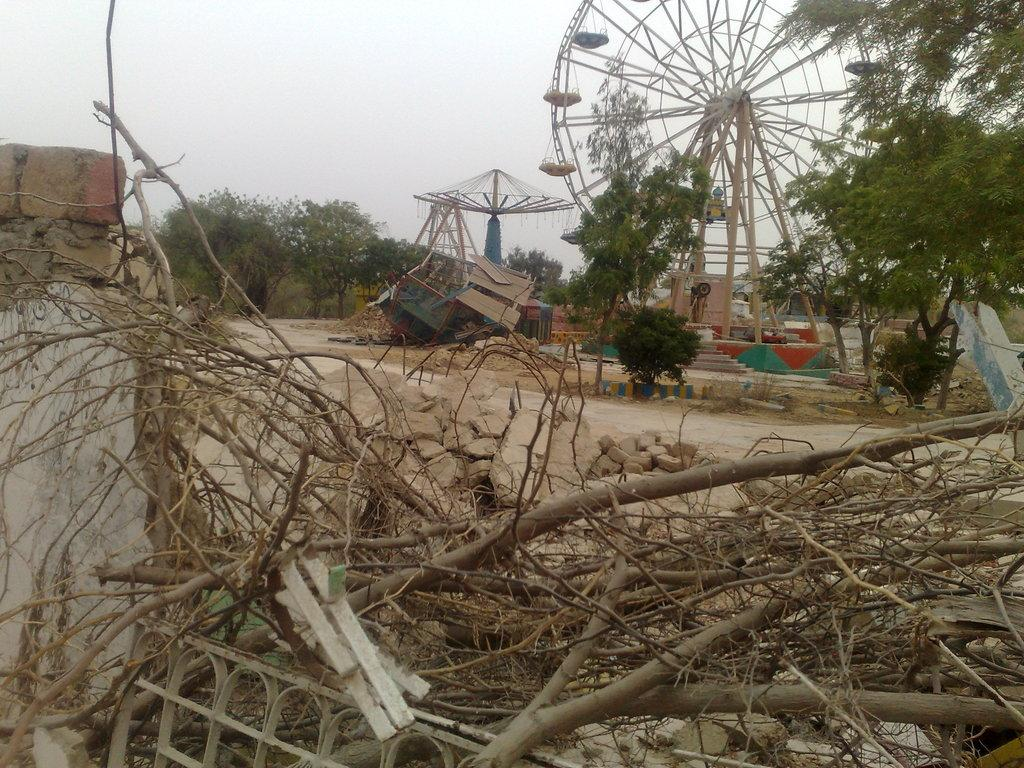What type of trees can be seen in the image? There are dried trees in the image. What can be seen in the background of the image? There are green trees and rides visible in the background of the image. What is the color of the sky in the image? The sky is white in color. How many centimeters does the jump rope measure in the image? There is no jump rope present in the image. 